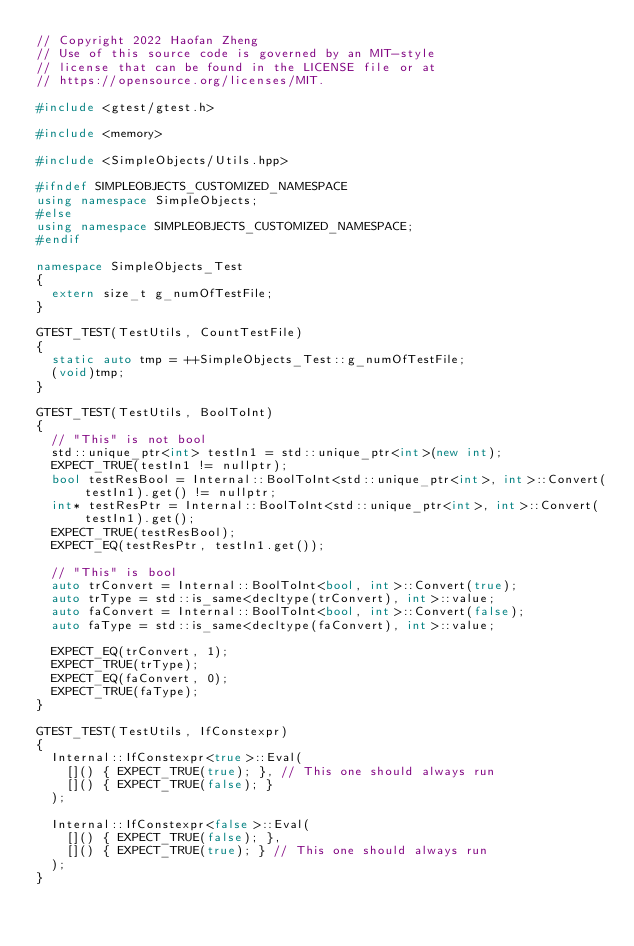<code> <loc_0><loc_0><loc_500><loc_500><_C++_>// Copyright 2022 Haofan Zheng
// Use of this source code is governed by an MIT-style
// license that can be found in the LICENSE file or at
// https://opensource.org/licenses/MIT.

#include <gtest/gtest.h>

#include <memory>

#include <SimpleObjects/Utils.hpp>

#ifndef SIMPLEOBJECTS_CUSTOMIZED_NAMESPACE
using namespace SimpleObjects;
#else
using namespace SIMPLEOBJECTS_CUSTOMIZED_NAMESPACE;
#endif

namespace SimpleObjects_Test
{
	extern size_t g_numOfTestFile;
}

GTEST_TEST(TestUtils, CountTestFile)
{
	static auto tmp = ++SimpleObjects_Test::g_numOfTestFile;
	(void)tmp;
}

GTEST_TEST(TestUtils, BoolToInt)
{
	// "This" is not bool
	std::unique_ptr<int> testIn1 = std::unique_ptr<int>(new int);
	EXPECT_TRUE(testIn1 != nullptr);
	bool testResBool = Internal::BoolToInt<std::unique_ptr<int>, int>::Convert(testIn1).get() != nullptr;
	int* testResPtr = Internal::BoolToInt<std::unique_ptr<int>, int>::Convert(testIn1).get();
	EXPECT_TRUE(testResBool);
	EXPECT_EQ(testResPtr, testIn1.get());

	// "This" is bool
	auto trConvert = Internal::BoolToInt<bool, int>::Convert(true);
	auto trType = std::is_same<decltype(trConvert), int>::value;
	auto faConvert = Internal::BoolToInt<bool, int>::Convert(false);
	auto faType = std::is_same<decltype(faConvert), int>::value;

	EXPECT_EQ(trConvert, 1);
	EXPECT_TRUE(trType);
	EXPECT_EQ(faConvert, 0);
	EXPECT_TRUE(faType);
}

GTEST_TEST(TestUtils, IfConstexpr)
{
	Internal::IfConstexpr<true>::Eval(
		[]() { EXPECT_TRUE(true); }, // This one should always run
		[]() { EXPECT_TRUE(false); }
	);

	Internal::IfConstexpr<false>::Eval(
		[]() { EXPECT_TRUE(false); },
		[]() { EXPECT_TRUE(true); } // This one should always run
	);
}
</code> 